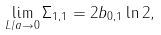<formula> <loc_0><loc_0><loc_500><loc_500>\lim _ { L / a \rightarrow 0 } \Sigma _ { 1 , 1 } = 2 b _ { 0 , 1 } \ln { 2 } ,</formula> 